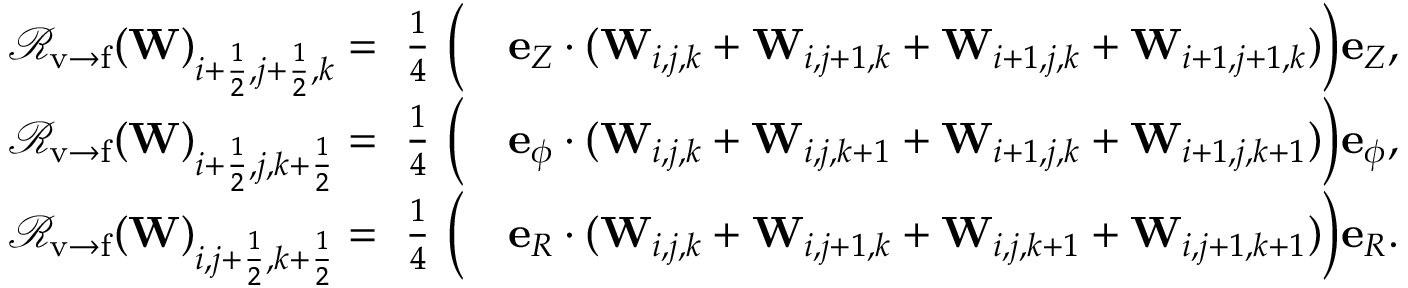<formula> <loc_0><loc_0><loc_500><loc_500>\begin{array} { r l } { { \mathcal { R } } _ { v \rightarrow f } ( W ) _ { i + \frac { 1 } { 2 } , j + \frac { 1 } { 2 } , k } = \frac { 1 } { 4 } { \left ( } } & e _ { Z } \cdot ( W _ { i , j , k } + W _ { i , j + 1 , k } + W _ { i + 1 , j , k } + W _ { i + 1 , j + 1 , k } ) { \right ) } e _ { Z } , } \\ { { \mathcal { R } } _ { v \rightarrow f } ( W ) _ { i + \frac { 1 } { 2 } , j , k + \frac { 1 } { 2 } } = \frac { 1 } { 4 } { \left ( } } & e _ { \phi } \cdot ( W _ { i , j , k } + W _ { i , j , k + 1 } + W _ { i + 1 , j , k } + W _ { i + 1 , j , k + 1 } ) { \right ) } e _ { \phi } , } \\ { { \mathcal { R } } _ { v \rightarrow f } ( W ) _ { i , j + \frac { 1 } { 2 } , k + \frac { 1 } { 2 } } = \frac { 1 } { 4 } { \left ( } } & e _ { R } \cdot ( W _ { i , j , k } + W _ { i , j + 1 , k } + W _ { i , j , k + 1 } + W _ { i , j + 1 , k + 1 } ) { \right ) } e _ { R } . } \end{array}</formula> 